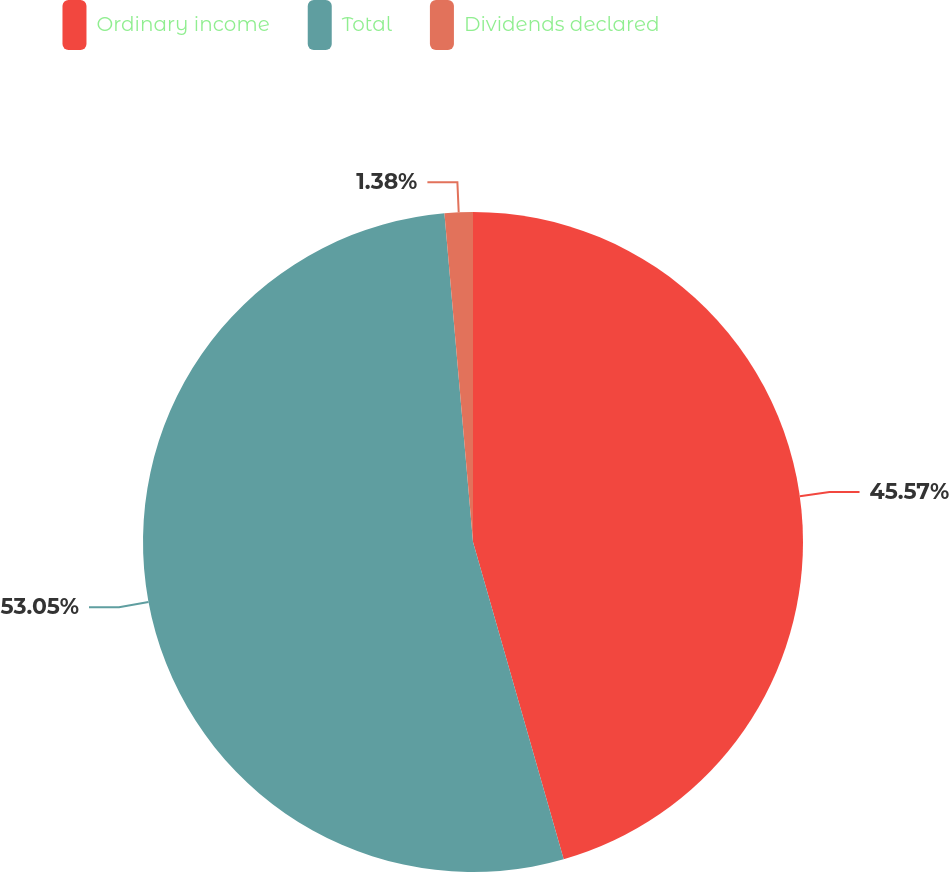Convert chart. <chart><loc_0><loc_0><loc_500><loc_500><pie_chart><fcel>Ordinary income<fcel>Total<fcel>Dividends declared<nl><fcel>45.57%<fcel>53.05%<fcel>1.38%<nl></chart> 